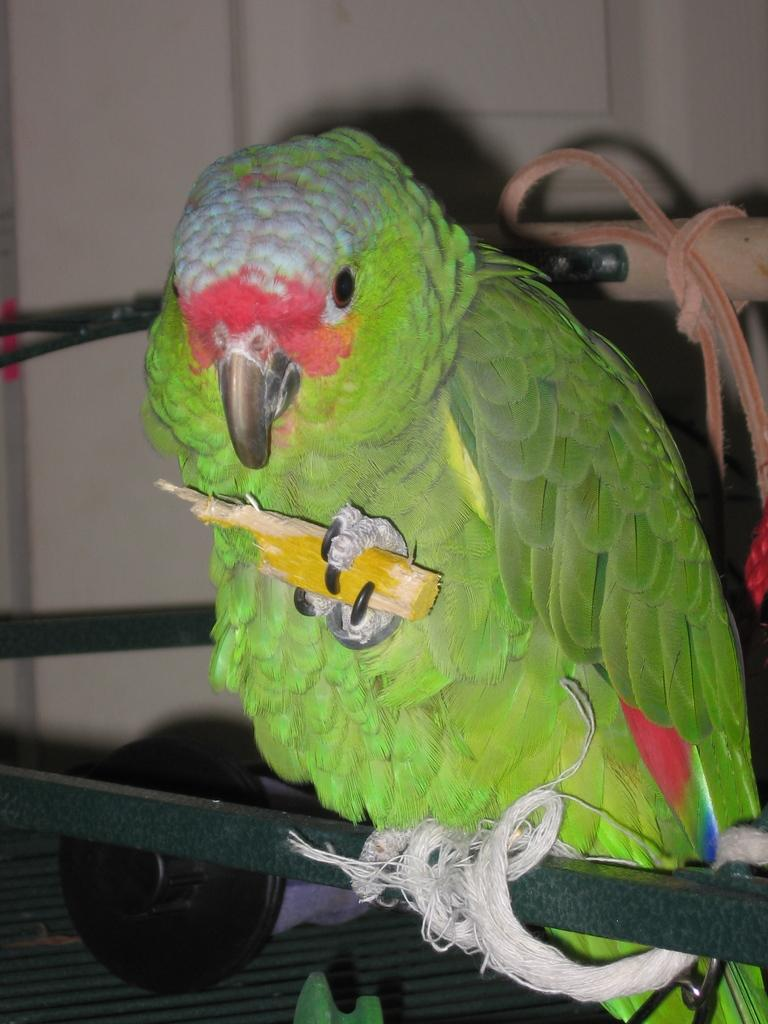What type of animal is in the image? There is a parrot in the image. What is the parrot sitting on? The parrot is sitting on a stick. What is the parrot holding with one of its legs? The parrot is holding something with one of its legs. Can you describe the wooden stick in the image? There is a wooden stick with a rope in the image. What type of vest is the parrot wearing in the image? The parrot is not wearing a vest in the image. What can you tell me about the parrot's teeth in the image? Parrots do not have teeth, so there is no mention of teeth in the image. 